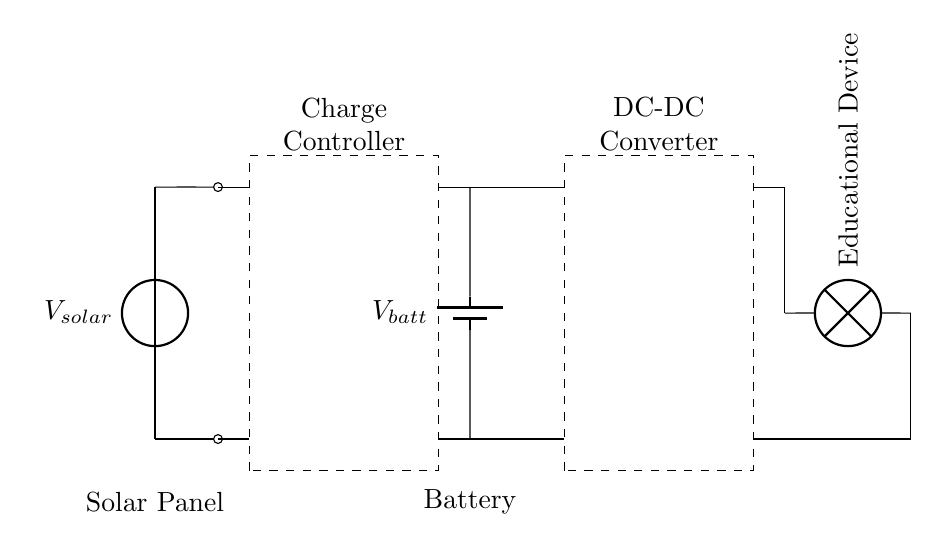What is the main component that converts solar energy into electrical energy? The solar panel is the main component that converts sunlight into electrical energy, indicated as a voltage source labeled V solar.
Answer: Solar Panel What type of controller is used in this circuit? The diagram shows a charge controller, which is clearly marked in a dashed rectangle and is responsible for regulating the voltage and current coming from the solar panel to the battery.
Answer: Charge Controller What is the voltage source connected to the battery? The battery is connected to a voltage source labeled V batt, which provides electrical energy to the load from the stored charge.
Answer: V batt How many major components are shown in the circuit? There are four major components: a solar panel, charge controller, battery, and a DC-DC converter. Counting them shows that these components are the core elements of this system.
Answer: Four What is the purpose of the DC-DC converter in the circuit? The DC-DC converter adjusts the voltage level of the electrical energy supplied to the educational device, making it suitable for the load's requirements. This is evident from its labeling and position in the circuit.
Answer: Adjust voltage Which component provides power to the educational device? The educational device is directly connected to the output from the DC-DC converter, which supplies it with the required electrical energy for operation.
Answer: DC-DC Converter How does the charge controller protect the battery? The charge controller regulates the flow of electricity from the solar panel to the battery, preventing overcharging and ensuring safe operation, which is essential for maintaining battery health.
Answer: Regulates flow 